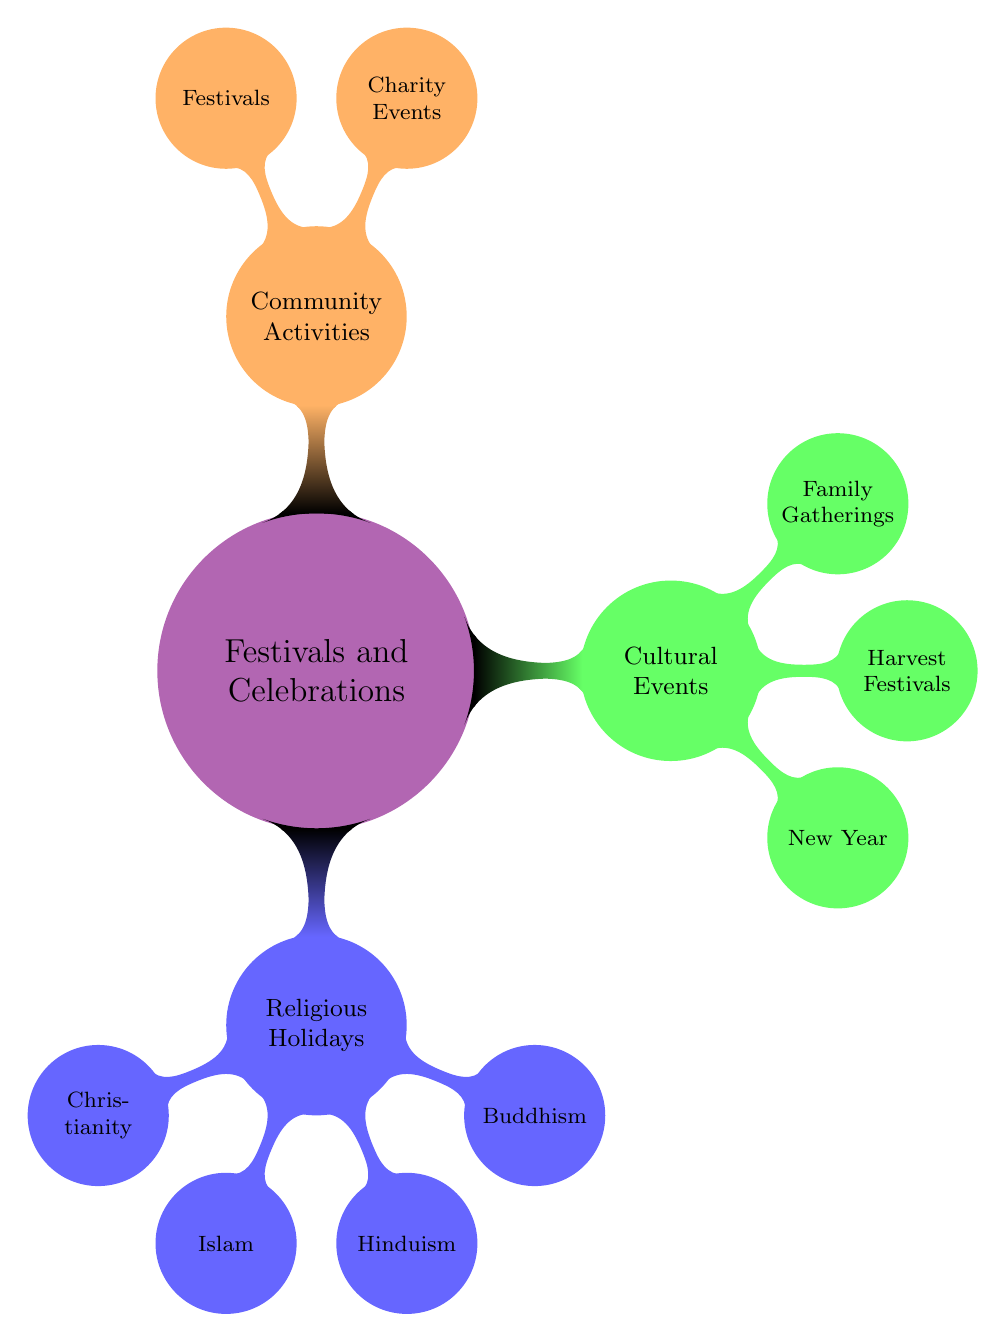What are the three main categories of festivals and celebrations? The main categories are outlined in the mind map. They are Religious Holidays, Cultural Events, and Community Activities.
Answer: Religious Holidays, Cultural Events, Community Activities Which religious group is associated with Christmas? The mind map specifies that Christmas is categorized under Christianity. Thus, Christianity is the associated religious group.
Answer: Christianity How many types of Religious Holidays are listed? By counting the branches under the Religious Holidays category in the mind map, there are four types of religions: Christianity, Islam, Hinduism, and Buddhism.
Answer: 4 Which Cultural Event is specifically mentioned for family gatherings? Referring to the mind map, Family Gatherings is a subcategory within Cultural Events, and it includes Reunions, Weddings, and Birthdays; thus, these events are specifically mentioned.
Answer: Family Gatherings What are the two main subcategories under Community Activities? By examining the Community Activities section in the mind map, we see two distinct subcategories: Charity Events and Festivals.
Answer: Charity Events, Festivals How many religions are listed under Religious Holidays? Counting the nodes under the Religious Holidays category, there are four: Christianity, Islam, Hinduism, and Buddhism.
Answer: 4 Which specific cultural event is celebrated universally at the beginning of the year? The mind map directly mentions New Year as the specific cultural event celebrated universally at the beginning of the year.
Answer: New Year What are the three types of festivals mentioned in the diagram? From the Community Activities section in the mind map, the three types of festivals are Carnivals, Parades, and Fairs.
Answer: Carnivals, Parades, Fairs Which religious holiday is celebrated by Muslims at the end of Ramadan? The mind map states that Eid al-Fitr is the religious holiday celebrated by Muslims at the end of Ramadan.
Answer: Eid al-Fitr 